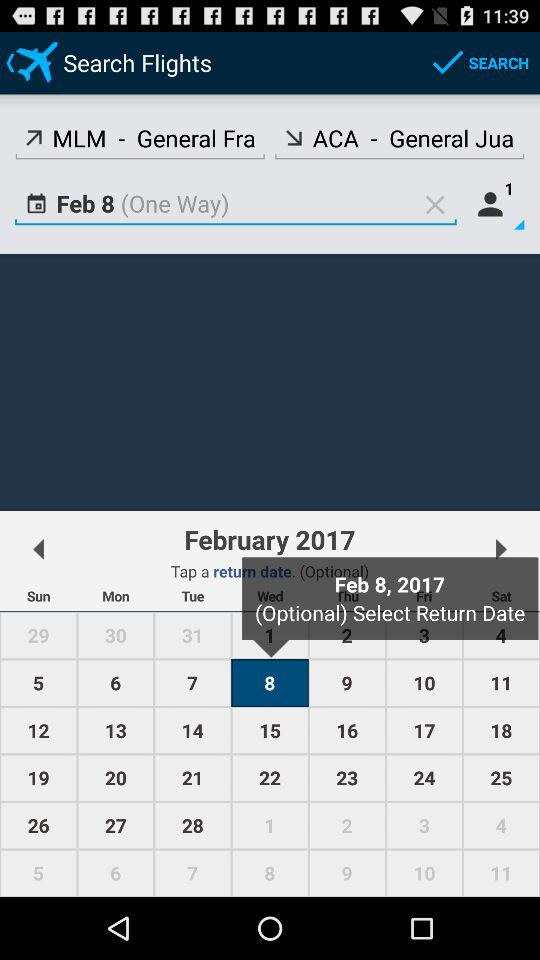Which number of passengers are there? There is 1 passenger. 